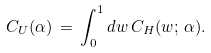<formula> <loc_0><loc_0><loc_500><loc_500>C _ { U } ( \alpha ) \, = \, \int _ { 0 } ^ { 1 } d w \, C _ { H } ( w ; \, \alpha ) .</formula> 